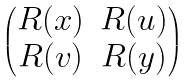Convert formula to latex. <formula><loc_0><loc_0><loc_500><loc_500>\begin{pmatrix} R ( x ) & R ( u ) \\ R ( v ) & R ( y ) \\ \end{pmatrix}</formula> 